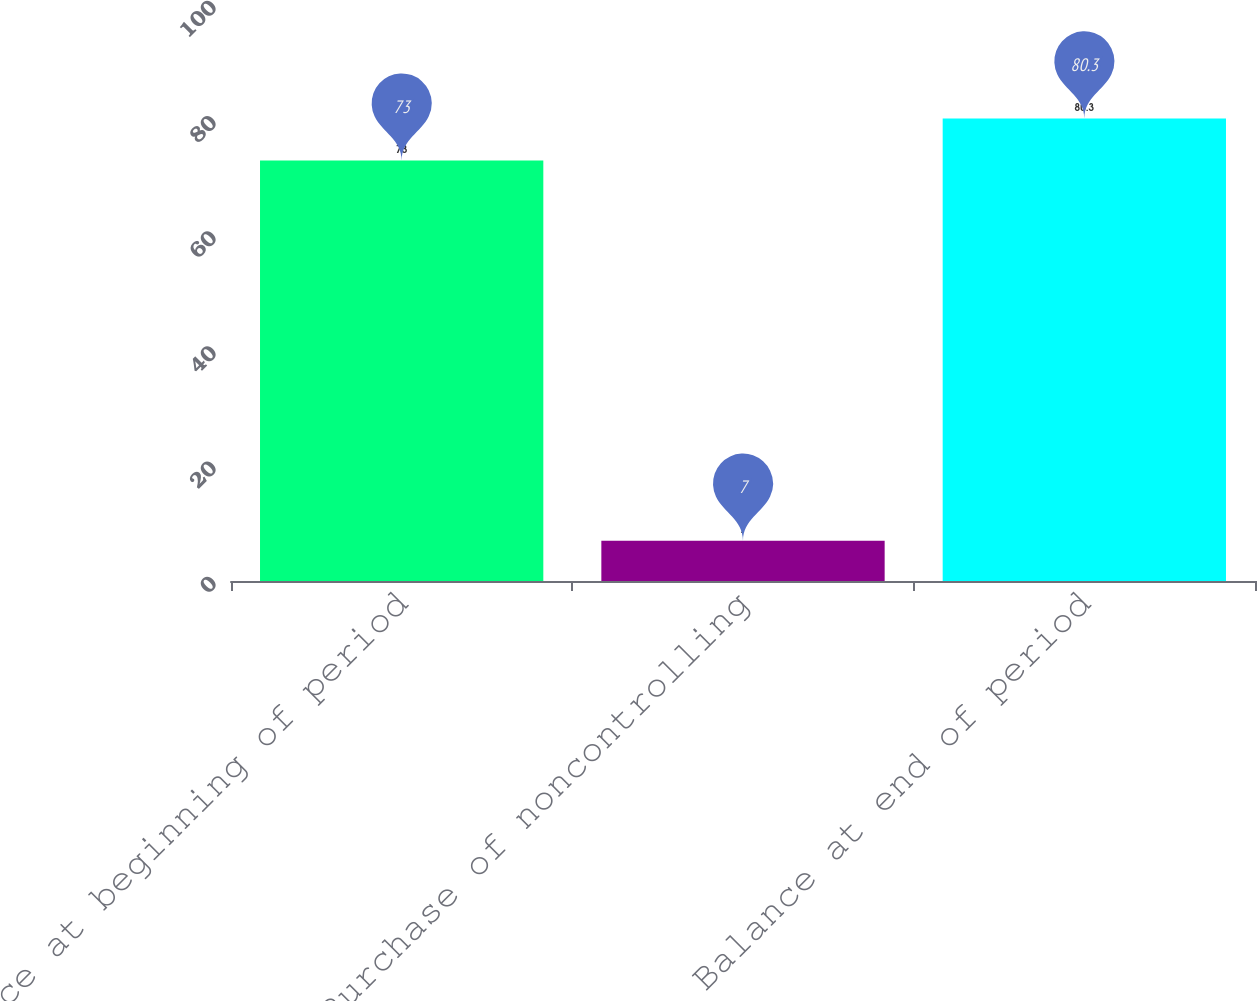<chart> <loc_0><loc_0><loc_500><loc_500><bar_chart><fcel>Balance at beginning of period<fcel>Purchase of noncontrolling<fcel>Balance at end of period<nl><fcel>73<fcel>7<fcel>80.3<nl></chart> 